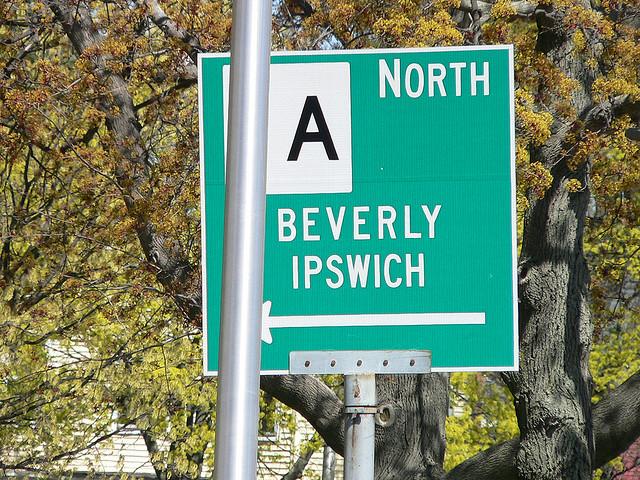Which way is the arrow pointing?
Concise answer only. Left. What is blocking part of the sign?
Quick response, please. Pole. What type of tree is in the background?
Short answer required. Oak. 